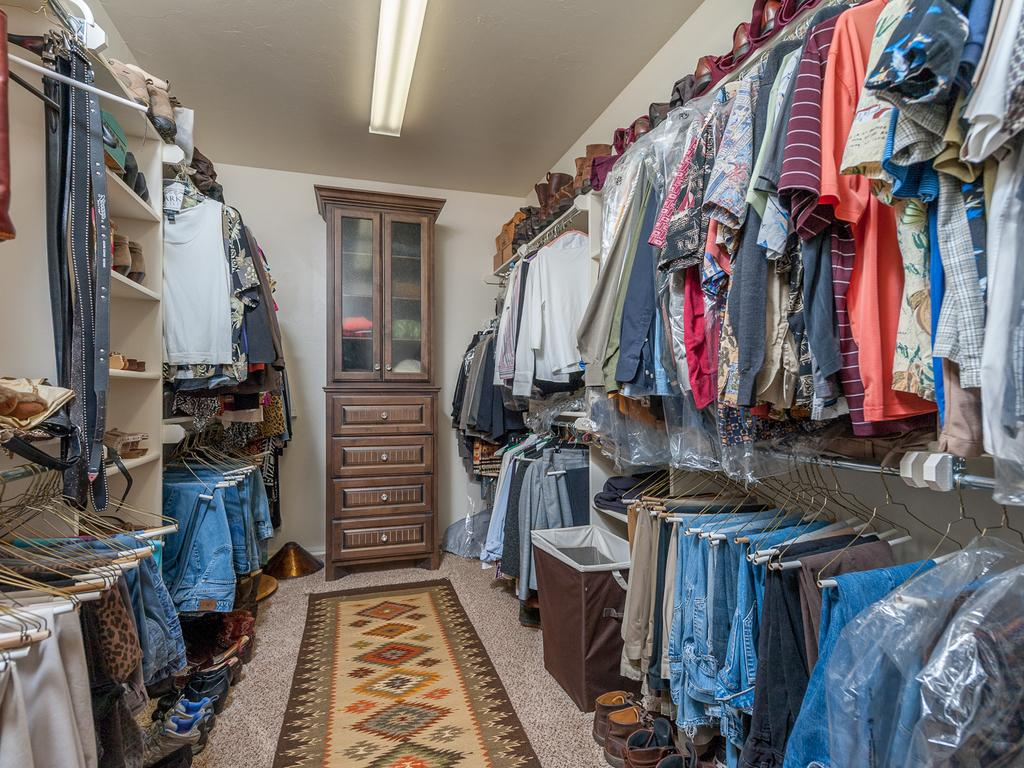What is the main structure in the center of the image? There is a wall in the center of the image. What type of flooring is visible in the image? There is a mat in the image. Is there any source of light in the image? Yes, there is a light in the image. What type of storage furniture is present in the image? There is a cupboard with objects in the image. Are there any drawers in the image? Yes, there are drawers in the image. What can be seen hanging in the image? There are hangers in the image. What type of clothing items are visible in the image? There are clothes in the image. What type of footwear is visible in the image? There are shoes in the image. Are there any other objects visible in the image? Yes, there are a few other objects in the image. How does the maid wash the clothes in the image? There is no maid present in the image, and the clothes are not being washed. 